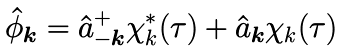Convert formula to latex. <formula><loc_0><loc_0><loc_500><loc_500>\hat { \phi } _ { \boldsymbol k } = \hat { a } ^ { + } _ { - \boldsymbol k } \chi _ { k } ^ { * } ( \tau ) + \hat { a } _ { \boldsymbol k } \chi _ { k } ( \tau )</formula> 